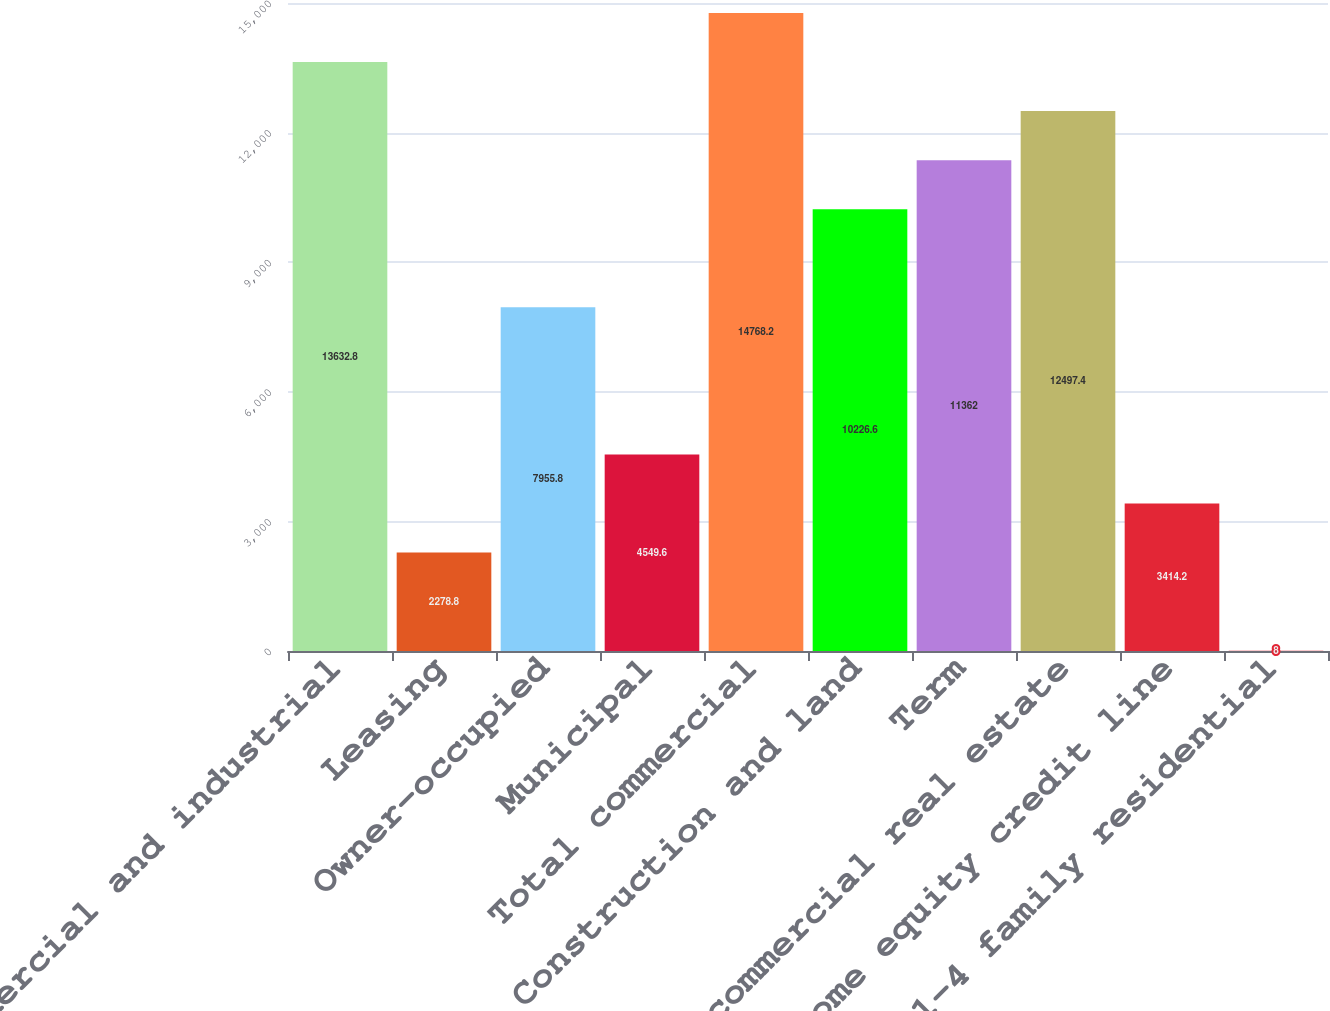<chart> <loc_0><loc_0><loc_500><loc_500><bar_chart><fcel>Commercial and industrial<fcel>Leasing<fcel>Owner-occupied<fcel>Municipal<fcel>Total commercial<fcel>Construction and land<fcel>Term<fcel>Total commercial real estate<fcel>Home equity credit line<fcel>1-4 family residential<nl><fcel>13632.8<fcel>2278.8<fcel>7955.8<fcel>4549.6<fcel>14768.2<fcel>10226.6<fcel>11362<fcel>12497.4<fcel>3414.2<fcel>8<nl></chart> 